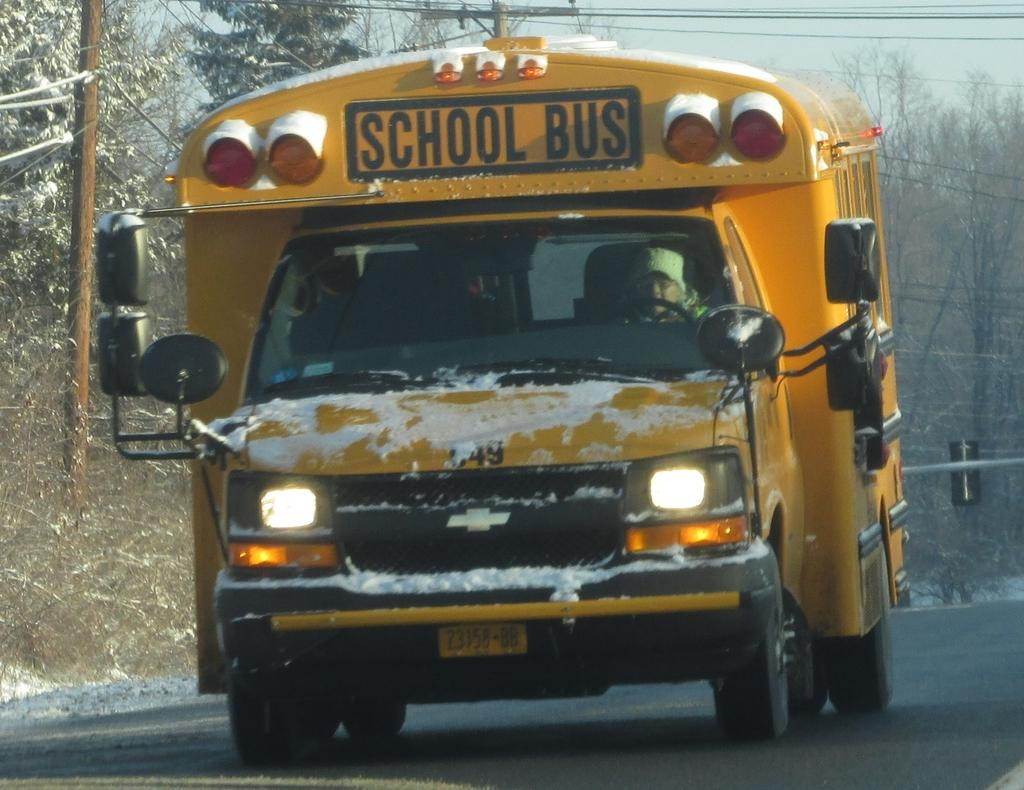What is the main subject of the image? There is a bus on a road in the image. What can be seen in the background of the image? There are trees, wires, and poles in the background of the image. What type of beef is being cooked on the bus in the image? There is no beef or cooking activity present in the image; it features a bus on a road with trees, wires, and poles in the background. 